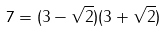Convert formula to latex. <formula><loc_0><loc_0><loc_500><loc_500>7 = ( 3 - \sqrt { 2 } ) ( 3 + \sqrt { 2 } )</formula> 